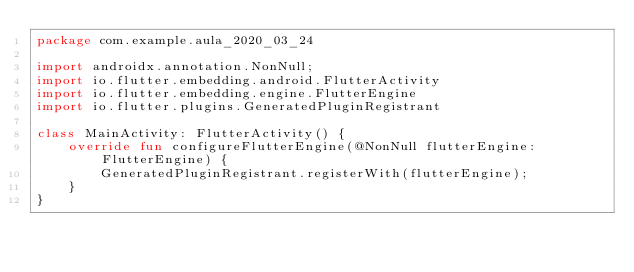Convert code to text. <code><loc_0><loc_0><loc_500><loc_500><_Kotlin_>package com.example.aula_2020_03_24

import androidx.annotation.NonNull;
import io.flutter.embedding.android.FlutterActivity
import io.flutter.embedding.engine.FlutterEngine
import io.flutter.plugins.GeneratedPluginRegistrant

class MainActivity: FlutterActivity() {
    override fun configureFlutterEngine(@NonNull flutterEngine: FlutterEngine) {
        GeneratedPluginRegistrant.registerWith(flutterEngine);
    }
}
</code> 